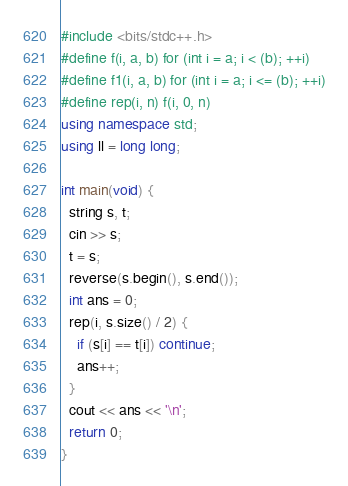Convert code to text. <code><loc_0><loc_0><loc_500><loc_500><_C++_>#include <bits/stdc++.h>
#define f(i, a, b) for (int i = a; i < (b); ++i)
#define f1(i, a, b) for (int i = a; i <= (b); ++i)
#define rep(i, n) f(i, 0, n)
using namespace std;
using ll = long long;

int main(void) {
  string s, t;
  cin >> s;
  t = s;
  reverse(s.begin(), s.end());
  int ans = 0;
  rep(i, s.size() / 2) {
    if (s[i] == t[i]) continue;
    ans++;
  }
  cout << ans << '\n';
  return 0;
}</code> 